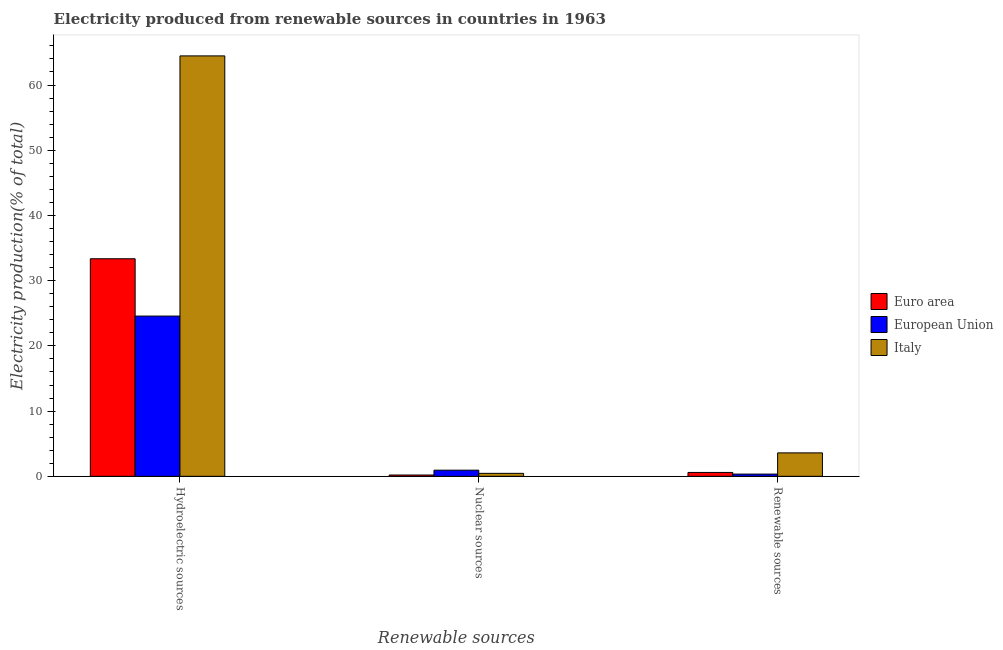How many different coloured bars are there?
Provide a succinct answer. 3. How many groups of bars are there?
Offer a terse response. 3. What is the label of the 1st group of bars from the left?
Keep it short and to the point. Hydroelectric sources. What is the percentage of electricity produced by nuclear sources in Euro area?
Make the answer very short. 0.2. Across all countries, what is the maximum percentage of electricity produced by renewable sources?
Your answer should be very brief. 3.59. Across all countries, what is the minimum percentage of electricity produced by hydroelectric sources?
Make the answer very short. 24.57. What is the total percentage of electricity produced by nuclear sources in the graph?
Offer a very short reply. 1.6. What is the difference between the percentage of electricity produced by hydroelectric sources in Euro area and that in European Union?
Your response must be concise. 8.79. What is the difference between the percentage of electricity produced by renewable sources in Euro area and the percentage of electricity produced by nuclear sources in Italy?
Offer a very short reply. 0.14. What is the average percentage of electricity produced by hydroelectric sources per country?
Provide a succinct answer. 40.8. What is the difference between the percentage of electricity produced by nuclear sources and percentage of electricity produced by hydroelectric sources in European Union?
Keep it short and to the point. -23.63. In how many countries, is the percentage of electricity produced by nuclear sources greater than 8 %?
Make the answer very short. 0. What is the ratio of the percentage of electricity produced by nuclear sources in European Union to that in Euro area?
Offer a terse response. 4.67. Is the percentage of electricity produced by nuclear sources in European Union less than that in Italy?
Provide a succinct answer. No. What is the difference between the highest and the second highest percentage of electricity produced by nuclear sources?
Give a very brief answer. 0.49. What is the difference between the highest and the lowest percentage of electricity produced by renewable sources?
Ensure brevity in your answer.  3.25. In how many countries, is the percentage of electricity produced by renewable sources greater than the average percentage of electricity produced by renewable sources taken over all countries?
Offer a very short reply. 1. Is the sum of the percentage of electricity produced by nuclear sources in Italy and European Union greater than the maximum percentage of electricity produced by hydroelectric sources across all countries?
Ensure brevity in your answer.  No. What does the 2nd bar from the left in Hydroelectric sources represents?
Your answer should be very brief. European Union. What does the 2nd bar from the right in Renewable sources represents?
Your response must be concise. European Union. How many bars are there?
Make the answer very short. 9. Are all the bars in the graph horizontal?
Provide a short and direct response. No. How many countries are there in the graph?
Ensure brevity in your answer.  3. Are the values on the major ticks of Y-axis written in scientific E-notation?
Ensure brevity in your answer.  No. Does the graph contain any zero values?
Your response must be concise. No. Does the graph contain grids?
Offer a very short reply. No. How many legend labels are there?
Give a very brief answer. 3. How are the legend labels stacked?
Offer a terse response. Vertical. What is the title of the graph?
Offer a very short reply. Electricity produced from renewable sources in countries in 1963. What is the label or title of the X-axis?
Make the answer very short. Renewable sources. What is the Electricity production(% of total) of Euro area in Hydroelectric sources?
Your answer should be very brief. 33.36. What is the Electricity production(% of total) in European Union in Hydroelectric sources?
Your response must be concise. 24.57. What is the Electricity production(% of total) in Italy in Hydroelectric sources?
Make the answer very short. 64.47. What is the Electricity production(% of total) of Euro area in Nuclear sources?
Keep it short and to the point. 0.2. What is the Electricity production(% of total) of European Union in Nuclear sources?
Ensure brevity in your answer.  0.94. What is the Electricity production(% of total) in Italy in Nuclear sources?
Ensure brevity in your answer.  0.45. What is the Electricity production(% of total) in Euro area in Renewable sources?
Your answer should be compact. 0.59. What is the Electricity production(% of total) in European Union in Renewable sources?
Your answer should be very brief. 0.34. What is the Electricity production(% of total) in Italy in Renewable sources?
Give a very brief answer. 3.59. Across all Renewable sources, what is the maximum Electricity production(% of total) in Euro area?
Provide a short and direct response. 33.36. Across all Renewable sources, what is the maximum Electricity production(% of total) in European Union?
Your answer should be compact. 24.57. Across all Renewable sources, what is the maximum Electricity production(% of total) of Italy?
Offer a terse response. 64.47. Across all Renewable sources, what is the minimum Electricity production(% of total) of Euro area?
Make the answer very short. 0.2. Across all Renewable sources, what is the minimum Electricity production(% of total) in European Union?
Provide a succinct answer. 0.34. Across all Renewable sources, what is the minimum Electricity production(% of total) in Italy?
Your response must be concise. 0.45. What is the total Electricity production(% of total) of Euro area in the graph?
Provide a short and direct response. 34.16. What is the total Electricity production(% of total) in European Union in the graph?
Provide a succinct answer. 25.86. What is the total Electricity production(% of total) of Italy in the graph?
Make the answer very short. 68.52. What is the difference between the Electricity production(% of total) in Euro area in Hydroelectric sources and that in Nuclear sources?
Your answer should be very brief. 33.16. What is the difference between the Electricity production(% of total) in European Union in Hydroelectric sources and that in Nuclear sources?
Offer a terse response. 23.63. What is the difference between the Electricity production(% of total) of Italy in Hydroelectric sources and that in Nuclear sources?
Offer a terse response. 64.01. What is the difference between the Electricity production(% of total) of Euro area in Hydroelectric sources and that in Renewable sources?
Keep it short and to the point. 32.77. What is the difference between the Electricity production(% of total) of European Union in Hydroelectric sources and that in Renewable sources?
Offer a very short reply. 24.23. What is the difference between the Electricity production(% of total) in Italy in Hydroelectric sources and that in Renewable sources?
Ensure brevity in your answer.  60.87. What is the difference between the Electricity production(% of total) in Euro area in Nuclear sources and that in Renewable sources?
Make the answer very short. -0.39. What is the difference between the Electricity production(% of total) in European Union in Nuclear sources and that in Renewable sources?
Offer a very short reply. 0.6. What is the difference between the Electricity production(% of total) of Italy in Nuclear sources and that in Renewable sources?
Your answer should be very brief. -3.14. What is the difference between the Electricity production(% of total) of Euro area in Hydroelectric sources and the Electricity production(% of total) of European Union in Nuclear sources?
Provide a succinct answer. 32.42. What is the difference between the Electricity production(% of total) in Euro area in Hydroelectric sources and the Electricity production(% of total) in Italy in Nuclear sources?
Offer a very short reply. 32.91. What is the difference between the Electricity production(% of total) of European Union in Hydroelectric sources and the Electricity production(% of total) of Italy in Nuclear sources?
Make the answer very short. 24.12. What is the difference between the Electricity production(% of total) in Euro area in Hydroelectric sources and the Electricity production(% of total) in European Union in Renewable sources?
Your answer should be compact. 33.02. What is the difference between the Electricity production(% of total) in Euro area in Hydroelectric sources and the Electricity production(% of total) in Italy in Renewable sources?
Your response must be concise. 29.77. What is the difference between the Electricity production(% of total) of European Union in Hydroelectric sources and the Electricity production(% of total) of Italy in Renewable sources?
Make the answer very short. 20.98. What is the difference between the Electricity production(% of total) in Euro area in Nuclear sources and the Electricity production(% of total) in European Union in Renewable sources?
Offer a very short reply. -0.14. What is the difference between the Electricity production(% of total) of Euro area in Nuclear sources and the Electricity production(% of total) of Italy in Renewable sources?
Provide a short and direct response. -3.39. What is the difference between the Electricity production(% of total) of European Union in Nuclear sources and the Electricity production(% of total) of Italy in Renewable sources?
Make the answer very short. -2.65. What is the average Electricity production(% of total) of Euro area per Renewable sources?
Your response must be concise. 11.39. What is the average Electricity production(% of total) in European Union per Renewable sources?
Your response must be concise. 8.62. What is the average Electricity production(% of total) in Italy per Renewable sources?
Ensure brevity in your answer.  22.84. What is the difference between the Electricity production(% of total) in Euro area and Electricity production(% of total) in European Union in Hydroelectric sources?
Make the answer very short. 8.79. What is the difference between the Electricity production(% of total) of Euro area and Electricity production(% of total) of Italy in Hydroelectric sources?
Provide a short and direct response. -31.11. What is the difference between the Electricity production(% of total) of European Union and Electricity production(% of total) of Italy in Hydroelectric sources?
Your answer should be compact. -39.9. What is the difference between the Electricity production(% of total) in Euro area and Electricity production(% of total) in European Union in Nuclear sources?
Your response must be concise. -0.74. What is the difference between the Electricity production(% of total) in Euro area and Electricity production(% of total) in Italy in Nuclear sources?
Provide a short and direct response. -0.25. What is the difference between the Electricity production(% of total) of European Union and Electricity production(% of total) of Italy in Nuclear sources?
Give a very brief answer. 0.49. What is the difference between the Electricity production(% of total) of Euro area and Electricity production(% of total) of European Union in Renewable sources?
Provide a succinct answer. 0.25. What is the difference between the Electricity production(% of total) of Euro area and Electricity production(% of total) of Italy in Renewable sources?
Give a very brief answer. -3. What is the difference between the Electricity production(% of total) of European Union and Electricity production(% of total) of Italy in Renewable sources?
Offer a terse response. -3.25. What is the ratio of the Electricity production(% of total) in Euro area in Hydroelectric sources to that in Nuclear sources?
Provide a succinct answer. 165.41. What is the ratio of the Electricity production(% of total) in European Union in Hydroelectric sources to that in Nuclear sources?
Your answer should be very brief. 26.1. What is the ratio of the Electricity production(% of total) in Italy in Hydroelectric sources to that in Nuclear sources?
Keep it short and to the point. 141.76. What is the ratio of the Electricity production(% of total) of Euro area in Hydroelectric sources to that in Renewable sources?
Provide a short and direct response. 56.14. What is the ratio of the Electricity production(% of total) in European Union in Hydroelectric sources to that in Renewable sources?
Your response must be concise. 71.68. What is the ratio of the Electricity production(% of total) in Italy in Hydroelectric sources to that in Renewable sources?
Provide a short and direct response. 17.94. What is the ratio of the Electricity production(% of total) in Euro area in Nuclear sources to that in Renewable sources?
Your answer should be compact. 0.34. What is the ratio of the Electricity production(% of total) of European Union in Nuclear sources to that in Renewable sources?
Provide a succinct answer. 2.75. What is the ratio of the Electricity production(% of total) in Italy in Nuclear sources to that in Renewable sources?
Give a very brief answer. 0.13. What is the difference between the highest and the second highest Electricity production(% of total) of Euro area?
Your answer should be compact. 32.77. What is the difference between the highest and the second highest Electricity production(% of total) of European Union?
Offer a very short reply. 23.63. What is the difference between the highest and the second highest Electricity production(% of total) of Italy?
Keep it short and to the point. 60.87. What is the difference between the highest and the lowest Electricity production(% of total) of Euro area?
Ensure brevity in your answer.  33.16. What is the difference between the highest and the lowest Electricity production(% of total) in European Union?
Your response must be concise. 24.23. What is the difference between the highest and the lowest Electricity production(% of total) in Italy?
Your response must be concise. 64.01. 